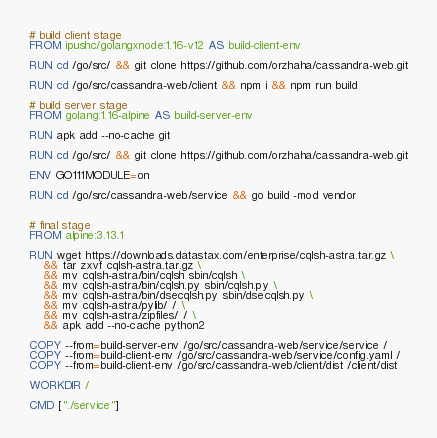Convert code to text. <code><loc_0><loc_0><loc_500><loc_500><_Dockerfile_># build client stage
FROM ipushc/golangxnode:1.16-v12 AS build-client-env

RUN cd /go/src/ && git clone https://github.com/orzhaha/cassandra-web.git

RUN cd /go/src/cassandra-web/client && npm i && npm run build

# build server stage
FROM golang:1.16-alpine AS build-server-env

RUN apk add --no-cache git

RUN cd /go/src/ && git clone https://github.com/orzhaha/cassandra-web.git

ENV GO111MODULE=on

RUN cd /go/src/cassandra-web/service && go build -mod vendor


# final stage
FROM alpine:3.13.1

RUN wget https://downloads.datastax.com/enterprise/cqlsh-astra.tar.gz \
    && tar zxvf cqlsh-astra.tar.gz \
    && mv cqlsh-astra/bin/cqlsh sbin/cqlsh \
    && mv cqlsh-astra/bin/cqlsh.py sbin/cqlsh.py \
    && mv cqlsh-astra/bin/dsecqlsh.py sbin/dsecqlsh.py \
    && mv cqlsh-astra/pylib/ / \
    && mv cqlsh-astra/zipfiles/ / \
    && apk add --no-cache python2

COPY --from=build-server-env /go/src/cassandra-web/service/service /
COPY --from=build-client-env /go/src/cassandra-web/service/config.yaml /
COPY --from=build-client-env /go/src/cassandra-web/client/dist /client/dist

WORKDIR /

CMD ["./service"]
</code> 